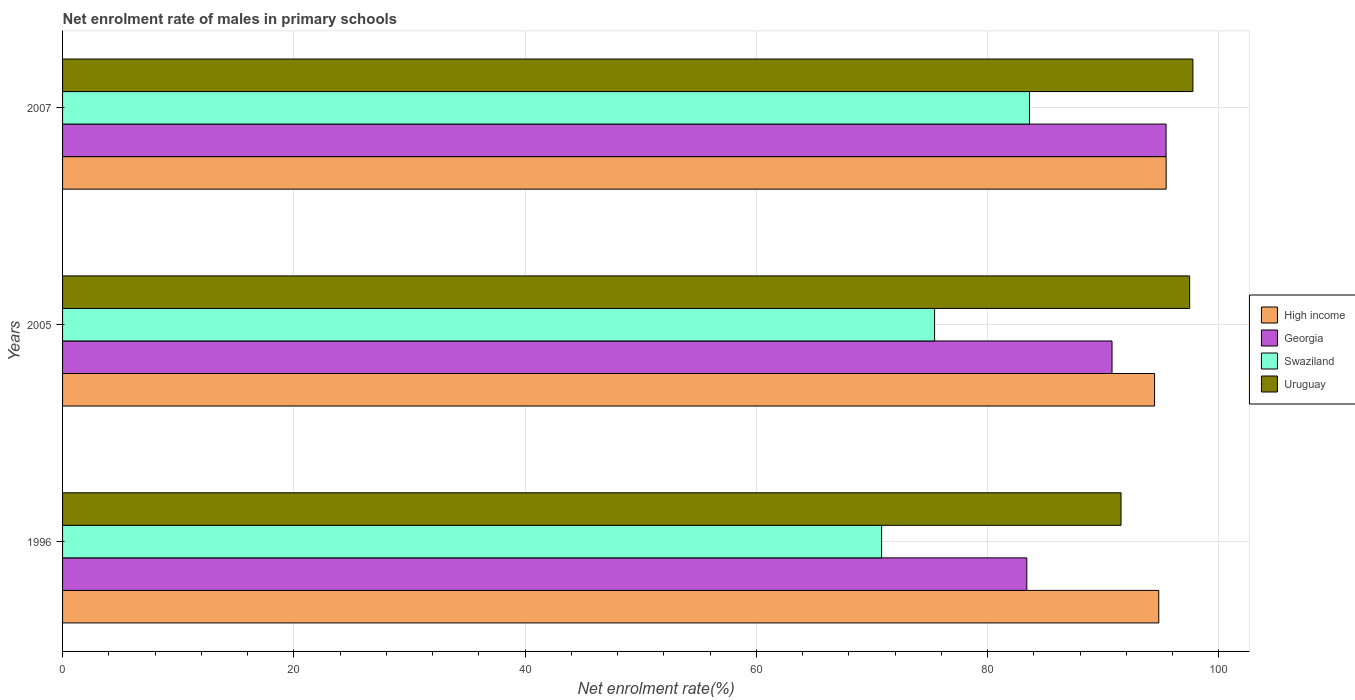How many different coloured bars are there?
Offer a terse response. 4. How many groups of bars are there?
Ensure brevity in your answer.  3. Are the number of bars per tick equal to the number of legend labels?
Keep it short and to the point. Yes. What is the label of the 2nd group of bars from the top?
Provide a succinct answer. 2005. In how many cases, is the number of bars for a given year not equal to the number of legend labels?
Keep it short and to the point. 0. What is the net enrolment rate of males in primary schools in Swaziland in 1996?
Your response must be concise. 70.83. Across all years, what is the maximum net enrolment rate of males in primary schools in High income?
Your answer should be very brief. 95.43. Across all years, what is the minimum net enrolment rate of males in primary schools in Georgia?
Offer a terse response. 83.38. In which year was the net enrolment rate of males in primary schools in High income minimum?
Give a very brief answer. 2005. What is the total net enrolment rate of males in primary schools in Uruguay in the graph?
Ensure brevity in your answer.  286.75. What is the difference between the net enrolment rate of males in primary schools in Uruguay in 1996 and that in 2005?
Your answer should be very brief. -5.93. What is the difference between the net enrolment rate of males in primary schools in Georgia in 2005 and the net enrolment rate of males in primary schools in High income in 2007?
Keep it short and to the point. -4.68. What is the average net enrolment rate of males in primary schools in Uruguay per year?
Your answer should be compact. 95.58. In the year 2005, what is the difference between the net enrolment rate of males in primary schools in Uruguay and net enrolment rate of males in primary schools in Georgia?
Your answer should be very brief. 6.71. In how many years, is the net enrolment rate of males in primary schools in Swaziland greater than 68 %?
Give a very brief answer. 3. What is the ratio of the net enrolment rate of males in primary schools in Swaziland in 1996 to that in 2007?
Provide a short and direct response. 0.85. Is the difference between the net enrolment rate of males in primary schools in Uruguay in 1996 and 2005 greater than the difference between the net enrolment rate of males in primary schools in Georgia in 1996 and 2005?
Offer a terse response. Yes. What is the difference between the highest and the second highest net enrolment rate of males in primary schools in Swaziland?
Your answer should be compact. 8.21. What is the difference between the highest and the lowest net enrolment rate of males in primary schools in Uruguay?
Provide a succinct answer. 6.22. In how many years, is the net enrolment rate of males in primary schools in Georgia greater than the average net enrolment rate of males in primary schools in Georgia taken over all years?
Offer a very short reply. 2. What does the 1st bar from the top in 1996 represents?
Give a very brief answer. Uruguay. What does the 4th bar from the bottom in 2007 represents?
Make the answer very short. Uruguay. Is it the case that in every year, the sum of the net enrolment rate of males in primary schools in Georgia and net enrolment rate of males in primary schools in Uruguay is greater than the net enrolment rate of males in primary schools in High income?
Your response must be concise. Yes. Are all the bars in the graph horizontal?
Provide a short and direct response. Yes. How many years are there in the graph?
Offer a very short reply. 3. Are the values on the major ticks of X-axis written in scientific E-notation?
Your answer should be compact. No. Does the graph contain grids?
Your answer should be very brief. Yes. Where does the legend appear in the graph?
Make the answer very short. Center right. How many legend labels are there?
Offer a terse response. 4. How are the legend labels stacked?
Offer a terse response. Vertical. What is the title of the graph?
Offer a very short reply. Net enrolment rate of males in primary schools. What is the label or title of the X-axis?
Provide a short and direct response. Net enrolment rate(%). What is the Net enrolment rate(%) in High income in 1996?
Provide a succinct answer. 94.8. What is the Net enrolment rate(%) of Georgia in 1996?
Provide a succinct answer. 83.38. What is the Net enrolment rate(%) in Swaziland in 1996?
Offer a terse response. 70.83. What is the Net enrolment rate(%) of Uruguay in 1996?
Give a very brief answer. 91.53. What is the Net enrolment rate(%) of High income in 2005?
Offer a terse response. 94.43. What is the Net enrolment rate(%) in Georgia in 2005?
Provide a succinct answer. 90.75. What is the Net enrolment rate(%) in Swaziland in 2005?
Offer a terse response. 75.41. What is the Net enrolment rate(%) of Uruguay in 2005?
Keep it short and to the point. 97.47. What is the Net enrolment rate(%) in High income in 2007?
Offer a terse response. 95.43. What is the Net enrolment rate(%) of Georgia in 2007?
Your answer should be compact. 95.43. What is the Net enrolment rate(%) of Swaziland in 2007?
Provide a short and direct response. 83.62. What is the Net enrolment rate(%) of Uruguay in 2007?
Offer a terse response. 97.75. Across all years, what is the maximum Net enrolment rate(%) in High income?
Your answer should be compact. 95.43. Across all years, what is the maximum Net enrolment rate(%) of Georgia?
Provide a short and direct response. 95.43. Across all years, what is the maximum Net enrolment rate(%) of Swaziland?
Your answer should be very brief. 83.62. Across all years, what is the maximum Net enrolment rate(%) of Uruguay?
Offer a terse response. 97.75. Across all years, what is the minimum Net enrolment rate(%) in High income?
Your response must be concise. 94.43. Across all years, what is the minimum Net enrolment rate(%) in Georgia?
Offer a terse response. 83.38. Across all years, what is the minimum Net enrolment rate(%) in Swaziland?
Keep it short and to the point. 70.83. Across all years, what is the minimum Net enrolment rate(%) of Uruguay?
Keep it short and to the point. 91.53. What is the total Net enrolment rate(%) of High income in the graph?
Give a very brief answer. 284.66. What is the total Net enrolment rate(%) of Georgia in the graph?
Offer a very short reply. 269.57. What is the total Net enrolment rate(%) in Swaziland in the graph?
Make the answer very short. 229.85. What is the total Net enrolment rate(%) in Uruguay in the graph?
Keep it short and to the point. 286.75. What is the difference between the Net enrolment rate(%) of High income in 1996 and that in 2005?
Your response must be concise. 0.36. What is the difference between the Net enrolment rate(%) of Georgia in 1996 and that in 2005?
Your answer should be compact. -7.37. What is the difference between the Net enrolment rate(%) in Swaziland in 1996 and that in 2005?
Your response must be concise. -4.58. What is the difference between the Net enrolment rate(%) in Uruguay in 1996 and that in 2005?
Your response must be concise. -5.93. What is the difference between the Net enrolment rate(%) in High income in 1996 and that in 2007?
Keep it short and to the point. -0.64. What is the difference between the Net enrolment rate(%) in Georgia in 1996 and that in 2007?
Offer a terse response. -12.04. What is the difference between the Net enrolment rate(%) of Swaziland in 1996 and that in 2007?
Your answer should be compact. -12.79. What is the difference between the Net enrolment rate(%) of Uruguay in 1996 and that in 2007?
Give a very brief answer. -6.22. What is the difference between the Net enrolment rate(%) of High income in 2005 and that in 2007?
Your answer should be compact. -1. What is the difference between the Net enrolment rate(%) in Georgia in 2005 and that in 2007?
Ensure brevity in your answer.  -4.67. What is the difference between the Net enrolment rate(%) in Swaziland in 2005 and that in 2007?
Ensure brevity in your answer.  -8.21. What is the difference between the Net enrolment rate(%) of Uruguay in 2005 and that in 2007?
Provide a short and direct response. -0.28. What is the difference between the Net enrolment rate(%) of High income in 1996 and the Net enrolment rate(%) of Georgia in 2005?
Provide a succinct answer. 4.04. What is the difference between the Net enrolment rate(%) of High income in 1996 and the Net enrolment rate(%) of Swaziland in 2005?
Your response must be concise. 19.39. What is the difference between the Net enrolment rate(%) in High income in 1996 and the Net enrolment rate(%) in Uruguay in 2005?
Your answer should be very brief. -2.67. What is the difference between the Net enrolment rate(%) of Georgia in 1996 and the Net enrolment rate(%) of Swaziland in 2005?
Your response must be concise. 7.98. What is the difference between the Net enrolment rate(%) of Georgia in 1996 and the Net enrolment rate(%) of Uruguay in 2005?
Offer a very short reply. -14.08. What is the difference between the Net enrolment rate(%) in Swaziland in 1996 and the Net enrolment rate(%) in Uruguay in 2005?
Make the answer very short. -26.64. What is the difference between the Net enrolment rate(%) of High income in 1996 and the Net enrolment rate(%) of Georgia in 2007?
Ensure brevity in your answer.  -0.63. What is the difference between the Net enrolment rate(%) in High income in 1996 and the Net enrolment rate(%) in Swaziland in 2007?
Your answer should be very brief. 11.18. What is the difference between the Net enrolment rate(%) in High income in 1996 and the Net enrolment rate(%) in Uruguay in 2007?
Your answer should be compact. -2.95. What is the difference between the Net enrolment rate(%) in Georgia in 1996 and the Net enrolment rate(%) in Swaziland in 2007?
Keep it short and to the point. -0.23. What is the difference between the Net enrolment rate(%) of Georgia in 1996 and the Net enrolment rate(%) of Uruguay in 2007?
Provide a succinct answer. -14.36. What is the difference between the Net enrolment rate(%) in Swaziland in 1996 and the Net enrolment rate(%) in Uruguay in 2007?
Offer a terse response. -26.92. What is the difference between the Net enrolment rate(%) of High income in 2005 and the Net enrolment rate(%) of Georgia in 2007?
Give a very brief answer. -0.99. What is the difference between the Net enrolment rate(%) of High income in 2005 and the Net enrolment rate(%) of Swaziland in 2007?
Your answer should be compact. 10.82. What is the difference between the Net enrolment rate(%) of High income in 2005 and the Net enrolment rate(%) of Uruguay in 2007?
Your answer should be very brief. -3.32. What is the difference between the Net enrolment rate(%) in Georgia in 2005 and the Net enrolment rate(%) in Swaziland in 2007?
Give a very brief answer. 7.14. What is the difference between the Net enrolment rate(%) of Georgia in 2005 and the Net enrolment rate(%) of Uruguay in 2007?
Give a very brief answer. -6.99. What is the difference between the Net enrolment rate(%) of Swaziland in 2005 and the Net enrolment rate(%) of Uruguay in 2007?
Give a very brief answer. -22.34. What is the average Net enrolment rate(%) of High income per year?
Keep it short and to the point. 94.89. What is the average Net enrolment rate(%) in Georgia per year?
Provide a succinct answer. 89.86. What is the average Net enrolment rate(%) in Swaziland per year?
Your response must be concise. 76.62. What is the average Net enrolment rate(%) of Uruguay per year?
Provide a succinct answer. 95.58. In the year 1996, what is the difference between the Net enrolment rate(%) of High income and Net enrolment rate(%) of Georgia?
Offer a terse response. 11.41. In the year 1996, what is the difference between the Net enrolment rate(%) in High income and Net enrolment rate(%) in Swaziland?
Your answer should be compact. 23.97. In the year 1996, what is the difference between the Net enrolment rate(%) in High income and Net enrolment rate(%) in Uruguay?
Your response must be concise. 3.26. In the year 1996, what is the difference between the Net enrolment rate(%) of Georgia and Net enrolment rate(%) of Swaziland?
Ensure brevity in your answer.  12.56. In the year 1996, what is the difference between the Net enrolment rate(%) in Georgia and Net enrolment rate(%) in Uruguay?
Your answer should be compact. -8.15. In the year 1996, what is the difference between the Net enrolment rate(%) of Swaziland and Net enrolment rate(%) of Uruguay?
Provide a short and direct response. -20.7. In the year 2005, what is the difference between the Net enrolment rate(%) in High income and Net enrolment rate(%) in Georgia?
Your response must be concise. 3.68. In the year 2005, what is the difference between the Net enrolment rate(%) of High income and Net enrolment rate(%) of Swaziland?
Offer a terse response. 19.02. In the year 2005, what is the difference between the Net enrolment rate(%) of High income and Net enrolment rate(%) of Uruguay?
Give a very brief answer. -3.03. In the year 2005, what is the difference between the Net enrolment rate(%) of Georgia and Net enrolment rate(%) of Swaziland?
Your answer should be very brief. 15.35. In the year 2005, what is the difference between the Net enrolment rate(%) in Georgia and Net enrolment rate(%) in Uruguay?
Provide a succinct answer. -6.71. In the year 2005, what is the difference between the Net enrolment rate(%) in Swaziland and Net enrolment rate(%) in Uruguay?
Offer a very short reply. -22.06. In the year 2007, what is the difference between the Net enrolment rate(%) of High income and Net enrolment rate(%) of Georgia?
Your response must be concise. 0.01. In the year 2007, what is the difference between the Net enrolment rate(%) of High income and Net enrolment rate(%) of Swaziland?
Make the answer very short. 11.82. In the year 2007, what is the difference between the Net enrolment rate(%) of High income and Net enrolment rate(%) of Uruguay?
Your answer should be very brief. -2.31. In the year 2007, what is the difference between the Net enrolment rate(%) of Georgia and Net enrolment rate(%) of Swaziland?
Give a very brief answer. 11.81. In the year 2007, what is the difference between the Net enrolment rate(%) in Georgia and Net enrolment rate(%) in Uruguay?
Offer a terse response. -2.32. In the year 2007, what is the difference between the Net enrolment rate(%) in Swaziland and Net enrolment rate(%) in Uruguay?
Provide a short and direct response. -14.13. What is the ratio of the Net enrolment rate(%) in High income in 1996 to that in 2005?
Keep it short and to the point. 1. What is the ratio of the Net enrolment rate(%) in Georgia in 1996 to that in 2005?
Keep it short and to the point. 0.92. What is the ratio of the Net enrolment rate(%) of Swaziland in 1996 to that in 2005?
Ensure brevity in your answer.  0.94. What is the ratio of the Net enrolment rate(%) of Uruguay in 1996 to that in 2005?
Your answer should be compact. 0.94. What is the ratio of the Net enrolment rate(%) in High income in 1996 to that in 2007?
Ensure brevity in your answer.  0.99. What is the ratio of the Net enrolment rate(%) in Georgia in 1996 to that in 2007?
Make the answer very short. 0.87. What is the ratio of the Net enrolment rate(%) of Swaziland in 1996 to that in 2007?
Provide a succinct answer. 0.85. What is the ratio of the Net enrolment rate(%) in Uruguay in 1996 to that in 2007?
Offer a terse response. 0.94. What is the ratio of the Net enrolment rate(%) in High income in 2005 to that in 2007?
Your answer should be very brief. 0.99. What is the ratio of the Net enrolment rate(%) of Georgia in 2005 to that in 2007?
Your answer should be compact. 0.95. What is the ratio of the Net enrolment rate(%) in Swaziland in 2005 to that in 2007?
Your answer should be compact. 0.9. What is the ratio of the Net enrolment rate(%) in Uruguay in 2005 to that in 2007?
Your response must be concise. 1. What is the difference between the highest and the second highest Net enrolment rate(%) of High income?
Give a very brief answer. 0.64. What is the difference between the highest and the second highest Net enrolment rate(%) of Georgia?
Provide a short and direct response. 4.67. What is the difference between the highest and the second highest Net enrolment rate(%) of Swaziland?
Offer a terse response. 8.21. What is the difference between the highest and the second highest Net enrolment rate(%) of Uruguay?
Offer a very short reply. 0.28. What is the difference between the highest and the lowest Net enrolment rate(%) in High income?
Offer a very short reply. 1. What is the difference between the highest and the lowest Net enrolment rate(%) of Georgia?
Your answer should be compact. 12.04. What is the difference between the highest and the lowest Net enrolment rate(%) in Swaziland?
Give a very brief answer. 12.79. What is the difference between the highest and the lowest Net enrolment rate(%) in Uruguay?
Provide a succinct answer. 6.22. 